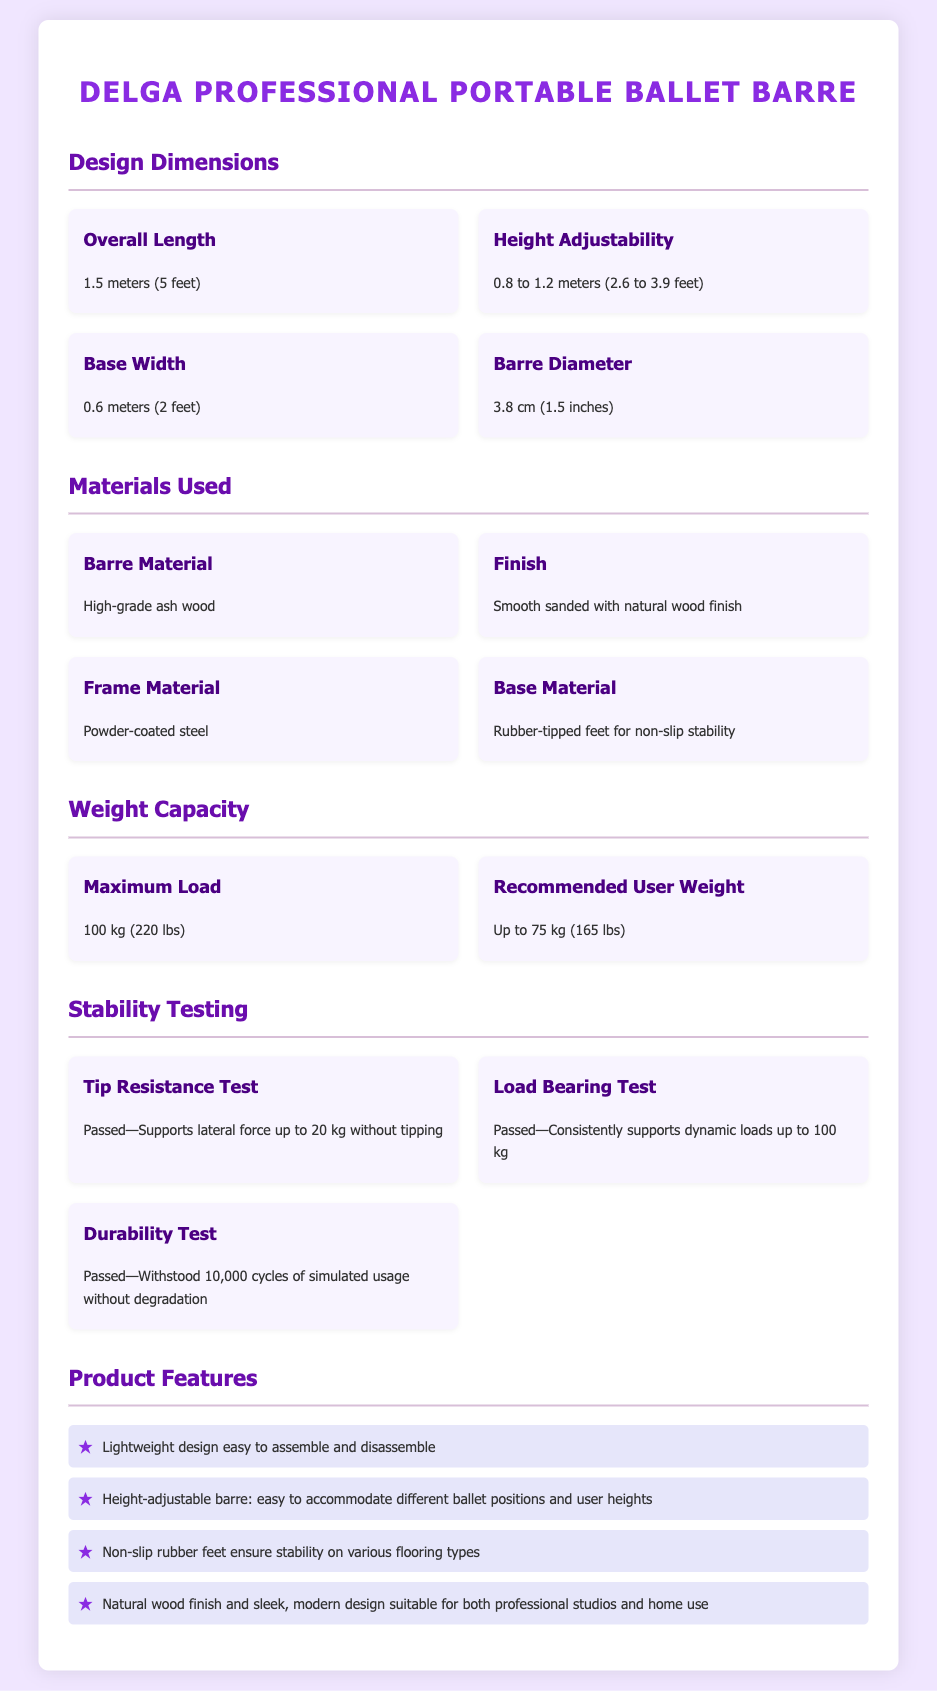what is the overall length of the ballet barre? The overall length is specified in the document as 1.5 meters (5 feet).
Answer: 1.5 meters (5 feet) what is the maximum load capacity for the ballet barre? The maximum load capacity is given as 100 kg (220 lbs) in the weight capacity section.
Answer: 100 kg (220 lbs) what material is the barre made from? The material used for the barre is identified as high-grade ash wood in the materials section.
Answer: High-grade ash wood what is the height range the barre can be adjusted to? The height adjustability is noted as ranging from 0.8 to 1.2 meters (2.6 to 3.9 feet).
Answer: 0.8 to 1.2 meters (2.6 to 3.9 feet) how many cycles did the durability test withstand? The durability test was noted to have withstood 10,000 cycles of simulated usage without degradation.
Answer: 10,000 cycles what is the primary feature of the barre's stability? The primary stability feature mentions non-slip rubber feet for stability on various flooring types.
Answer: Non-slip rubber feet what is the recommended user weight for the barre? The recommended user weight is mentioned as up to 75 kg (165 lbs) in the weight capacity section.
Answer: Up to 75 kg (165 lbs) how does the ballet barre accommodate different user heights? The design feature noted for accommodating different user heights is the height-adjustable barre.
Answer: Height-adjustable barre what type of finish does the barre have? The finish of the barre is described as smooth sanded with a natural wood finish.
Answer: Smooth sanded with natural wood finish 